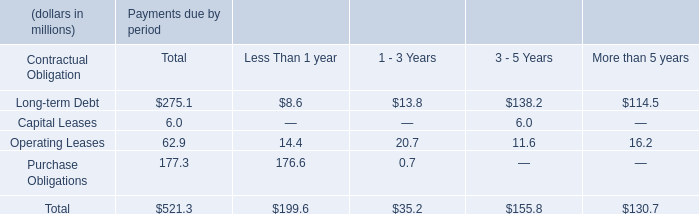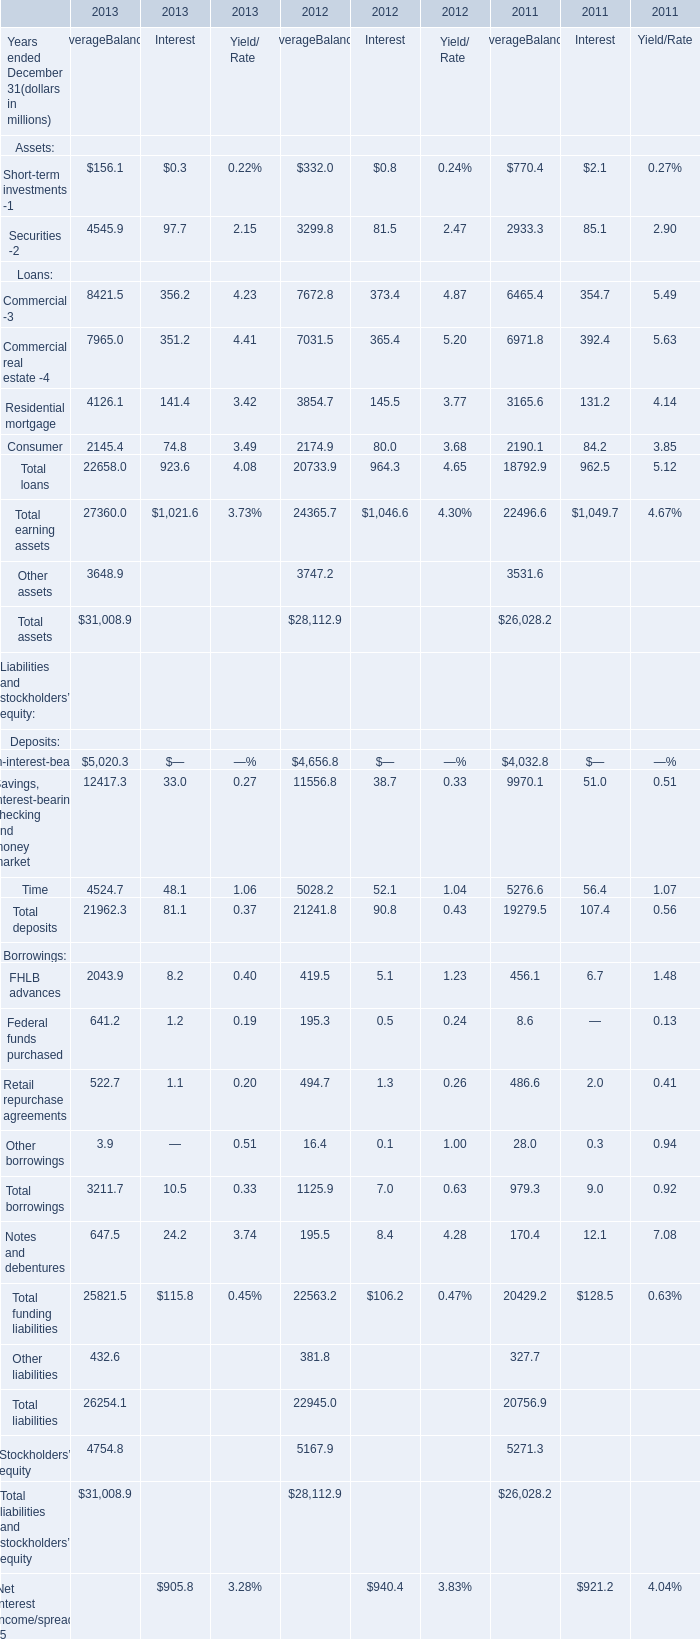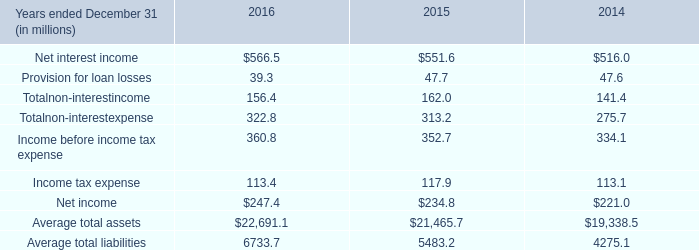What is the average value of Short-term investments -1 for AverageBalance in 2013 and Net interest income in 2016? 
Computations: ((156.1 + 566.5) / 2)
Answer: 361.3. 